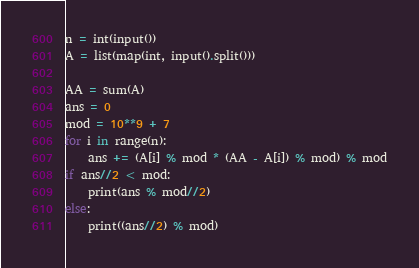<code> <loc_0><loc_0><loc_500><loc_500><_Python_>n = int(input())
A = list(map(int, input().split()))

AA = sum(A)
ans = 0
mod = 10**9 + 7
for i in range(n):
    ans += (A[i] % mod * (AA - A[i]) % mod) % mod
if ans//2 < mod:
    print(ans % mod//2)
else:
    print((ans//2) % mod)
</code> 